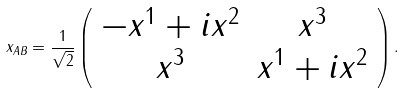<formula> <loc_0><loc_0><loc_500><loc_500>x _ { A B } = \frac { 1 } { \sqrt { 2 } } \left ( \begin{array} { c c } - x ^ { 1 } + i x ^ { 2 } & x ^ { 3 } \\ x ^ { 3 } & x ^ { 1 } + i x ^ { 2 } \end{array} \right ) .</formula> 